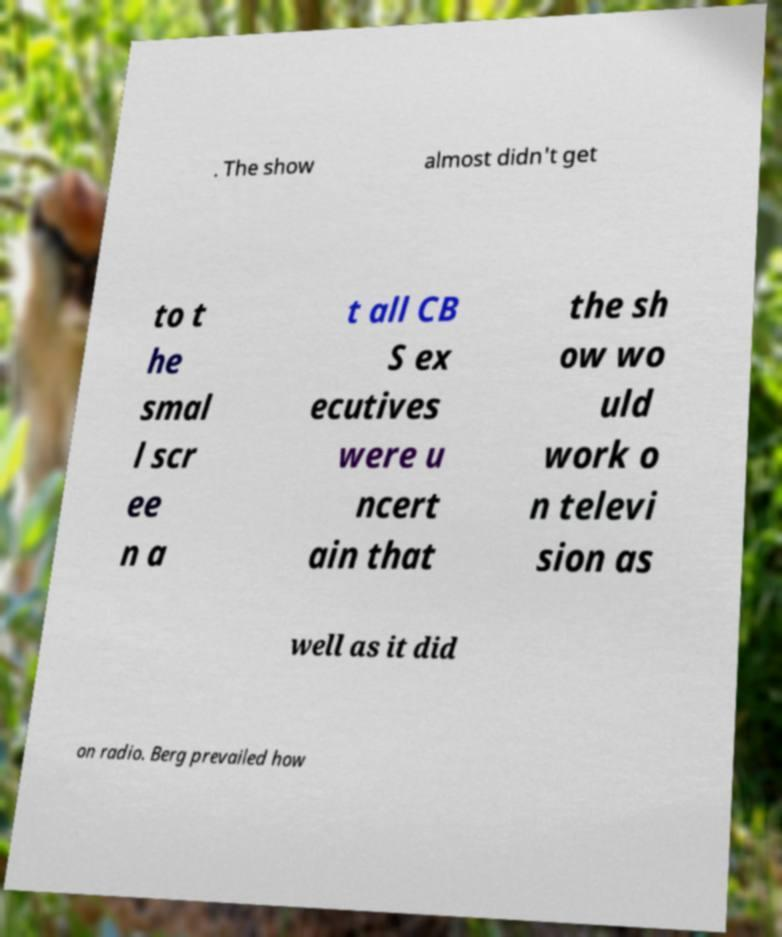For documentation purposes, I need the text within this image transcribed. Could you provide that? . The show almost didn't get to t he smal l scr ee n a t all CB S ex ecutives were u ncert ain that the sh ow wo uld work o n televi sion as well as it did on radio. Berg prevailed how 